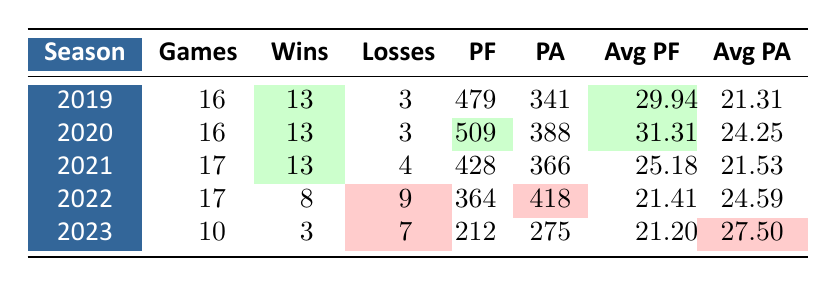What was the highest average points scored by the Packers in a season over the last five seasons? The highest average points scored is found in the 2020 season, with an average of 31.31 points.
Answer: 31.31 How many games did the Packers play in the 2021 season? The table shows the Packers played 17 games in the 2021 season.
Answer: 17 Did the Packers have a losing record in the 2022 season? In the 2022 season, the Packers won 8 games and lost 9, indicating a losing record.
Answer: Yes What is the total number of wins for the Packers over the last five seasons? Adding the wins from each season: 13 (2019) + 13 (2020) + 13 (2021) + 8 (2022) + 3 (2023) gives a total of 70 wins.
Answer: 70 What is the difference between points scored and points against in the 2020 season? In the 2020 season, the Packers scored 509 points and allowed 388 points. The difference is 509 - 388 = 121 points.
Answer: 121 In which seasons did the Packers score more than 29 points on average? The Packers scored more than 29 points on average in the 2019 (29.94) and 2020 (31.31) seasons.
Answer: 2019, 2020 What was the trend in average points allowed from the 2019 to the 2023 season? To see the trend in average points allowed, list the averages: 21.31 (2019), 24.25 (2020), 21.53 (2021), 24.59 (2022), and 27.50 (2023). The trend shows an increase over the seasons, notably rising in 2023.
Answer: Increased How many total points did the Packers score in the 2022 season? The table indicates the Packers scored 364 points in the 2022 season.
Answer: 364 What was the average points allowed in the 2021 season? According to the table, the average points allowed by the Packers in the 2021 season is 21.53.
Answer: 21.53 Which season had the highest number of total points scored by the Packers? The 2020 season had the highest total points scored, which is 509 points.
Answer: 2020 